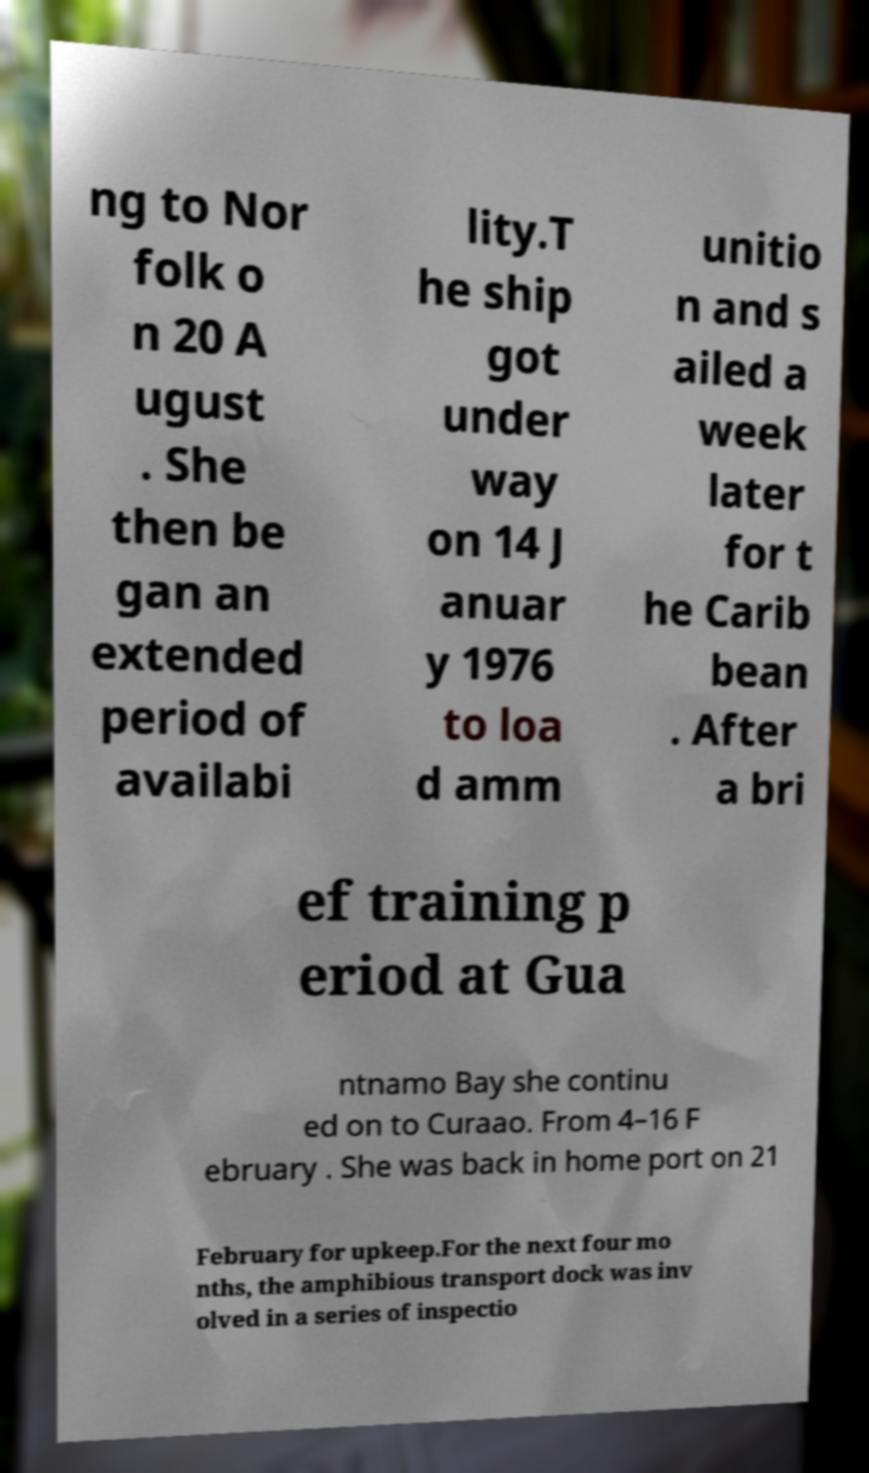Can you accurately transcribe the text from the provided image for me? ng to Nor folk o n 20 A ugust . She then be gan an extended period of availabi lity.T he ship got under way on 14 J anuar y 1976 to loa d amm unitio n and s ailed a week later for t he Carib bean . After a bri ef training p eriod at Gua ntnamo Bay she continu ed on to Curaao. From 4–16 F ebruary . She was back in home port on 21 February for upkeep.For the next four mo nths, the amphibious transport dock was inv olved in a series of inspectio 